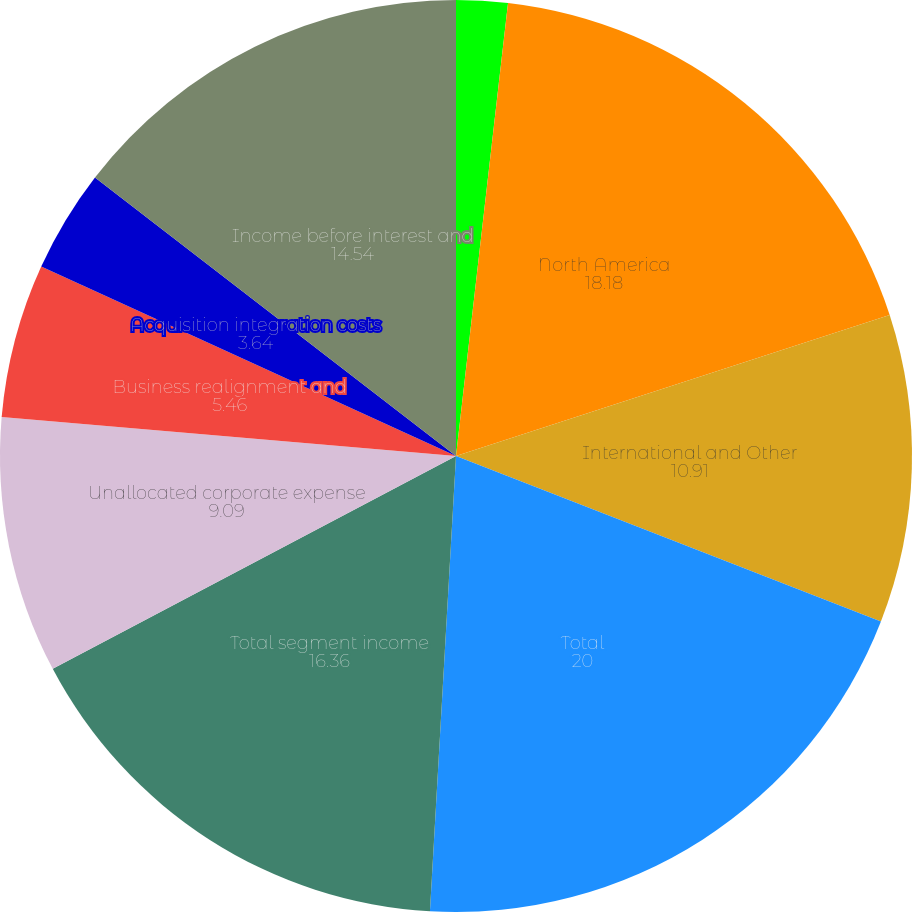Convert chart. <chart><loc_0><loc_0><loc_500><loc_500><pie_chart><fcel>For the years ended December<fcel>North America<fcel>International and Other<fcel>Total<fcel>Total segment income<fcel>Unallocated corporate expense<fcel>Business realignment and<fcel>Non-service related pension<fcel>Acquisition integration costs<fcel>Income before interest and<nl><fcel>1.82%<fcel>18.18%<fcel>10.91%<fcel>20.0%<fcel>16.36%<fcel>9.09%<fcel>5.46%<fcel>0.0%<fcel>3.64%<fcel>14.54%<nl></chart> 